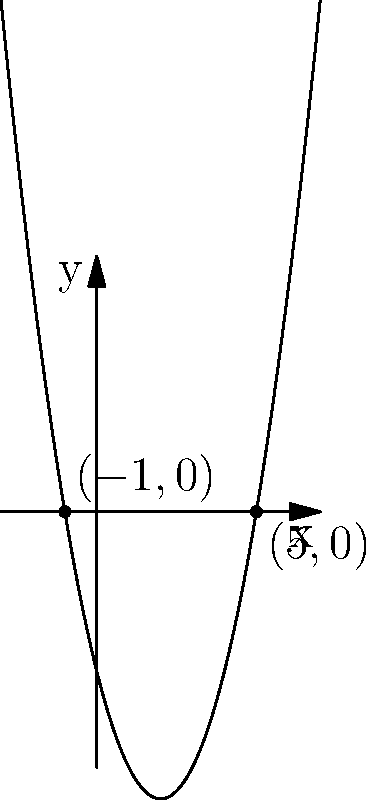The graph above represents a quadratic function $f(x) = ax^2 + bx + c$. Based on the graph, what are the roots of this polynomial equation? To find the roots of a quadratic polynomial using a graph, we need to identify the x-intercepts, which are the points where the parabola crosses the x-axis.

Step 1: Observe the graph and locate the points where the curve intersects the x-axis.

Step 2: We can see two intersection points: one on the negative side of the x-axis and one on the positive side.

Step 3: The x-coordinates of these points are the roots of the polynomial.

Step 4: From the graph, we can see that the intersection points are at $x = -1$ and $x = 5$.

Therefore, the roots of the quadratic polynomial are $x = -1$ and $x = 5$.
Answer: $x = -1$ and $x = 5$ 